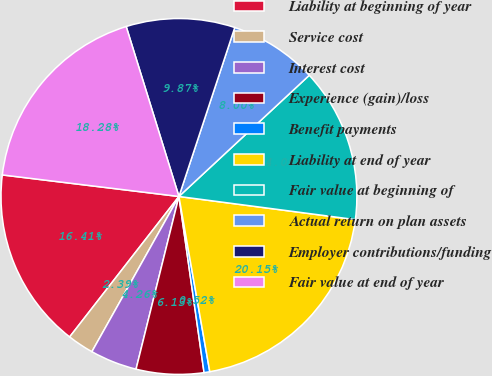<chart> <loc_0><loc_0><loc_500><loc_500><pie_chart><fcel>Liability at beginning of year<fcel>Service cost<fcel>Interest cost<fcel>Experience (gain)/loss<fcel>Benefit payments<fcel>Liability at end of year<fcel>Fair value at beginning of<fcel>Actual return on plan assets<fcel>Employer contributions/funding<fcel>Fair value at end of year<nl><fcel>16.41%<fcel>2.39%<fcel>4.26%<fcel>6.13%<fcel>0.52%<fcel>20.15%<fcel>14.0%<fcel>8.0%<fcel>9.87%<fcel>18.28%<nl></chart> 